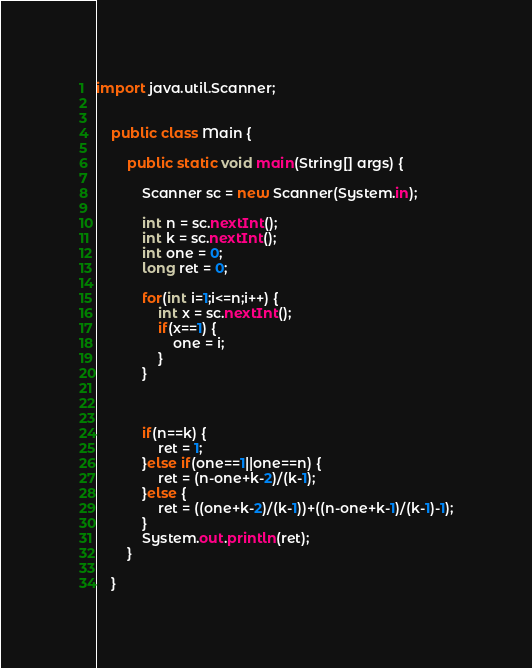Convert code to text. <code><loc_0><loc_0><loc_500><loc_500><_Java_>import java.util.Scanner;


	public class Main {

		public static void main(String[] args) {

			Scanner sc = new Scanner(System.in);

			int n = sc.nextInt();
			int k = sc.nextInt();
			int one = 0;
			long ret = 0;
			
			for(int i=1;i<=n;i++) {
				int x = sc.nextInt();
				if(x==1) {
					one = i;
				}
			}
			
			
			
			if(n==k) {
				ret = 1;
			}else if(one==1||one==n) {
				ret = (n-one+k-2)/(k-1);				
			}else {
				ret = ((one+k-2)/(k-1))+((n-one+k-1)/(k-1)-1);
			}
			System.out.println(ret);
		}

	}
</code> 